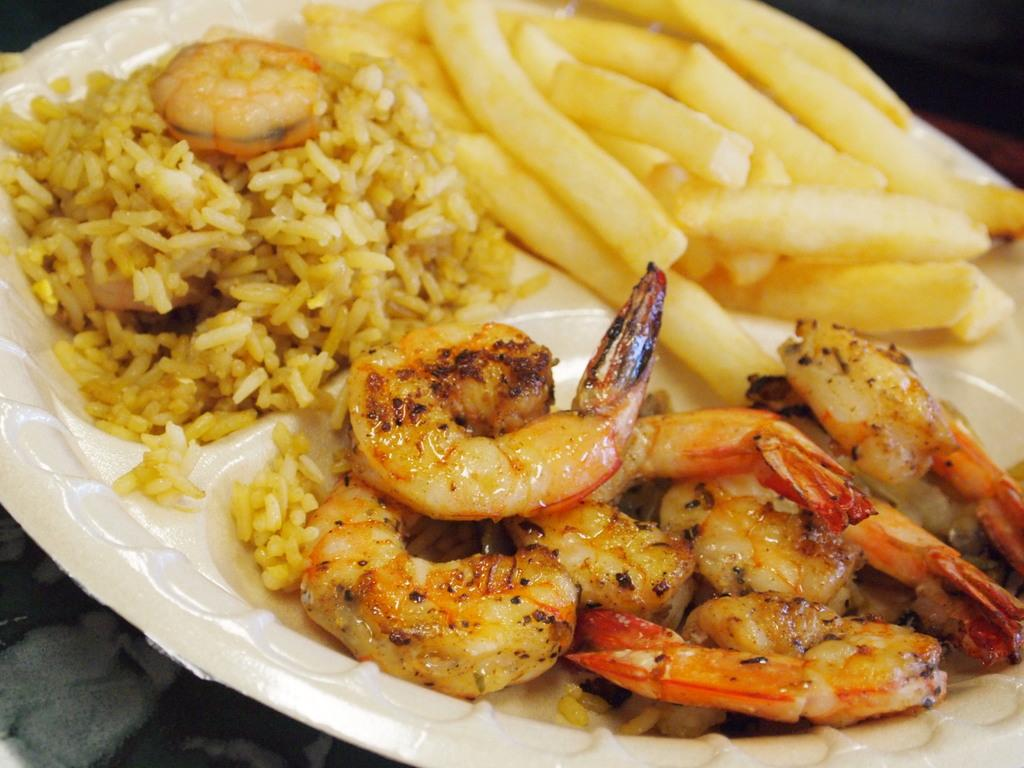What is the color of the plate in the image? The plate in the image is white. What is on the plate? There is rice on the plate. What other food item can be seen in the image? There are french fries in the image. What type of music is being played in the background of the image? There is no information about music in the image, as it only shows a plate with rice and french fries. 